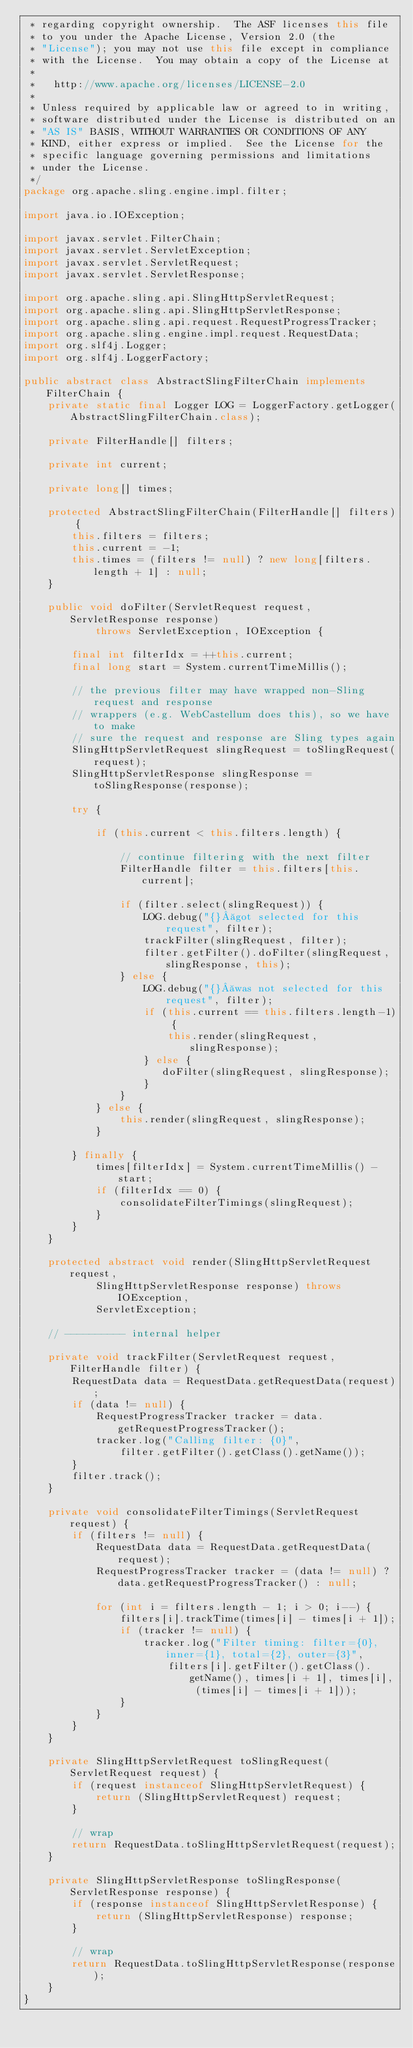<code> <loc_0><loc_0><loc_500><loc_500><_Java_> * regarding copyright ownership.  The ASF licenses this file
 * to you under the Apache License, Version 2.0 (the
 * "License"); you may not use this file except in compliance
 * with the License.  You may obtain a copy of the License at
 *
 *   http://www.apache.org/licenses/LICENSE-2.0
 *
 * Unless required by applicable law or agreed to in writing,
 * software distributed under the License is distributed on an
 * "AS IS" BASIS, WITHOUT WARRANTIES OR CONDITIONS OF ANY
 * KIND, either express or implied.  See the License for the
 * specific language governing permissions and limitations
 * under the License.
 */
package org.apache.sling.engine.impl.filter;

import java.io.IOException;

import javax.servlet.FilterChain;
import javax.servlet.ServletException;
import javax.servlet.ServletRequest;
import javax.servlet.ServletResponse;

import org.apache.sling.api.SlingHttpServletRequest;
import org.apache.sling.api.SlingHttpServletResponse;
import org.apache.sling.api.request.RequestProgressTracker;
import org.apache.sling.engine.impl.request.RequestData;
import org.slf4j.Logger;
import org.slf4j.LoggerFactory;

public abstract class AbstractSlingFilterChain implements FilterChain {
    private static final Logger LOG = LoggerFactory.getLogger(AbstractSlingFilterChain.class);

    private FilterHandle[] filters;

    private int current;

    private long[] times;

    protected AbstractSlingFilterChain(FilterHandle[] filters) {
        this.filters = filters;
        this.current = -1;
        this.times = (filters != null) ? new long[filters.length + 1] : null;
    }

    public void doFilter(ServletRequest request, ServletResponse response)
            throws ServletException, IOException {

        final int filterIdx = ++this.current;
        final long start = System.currentTimeMillis();

        // the previous filter may have wrapped non-Sling request and response
        // wrappers (e.g. WebCastellum does this), so we have to make
        // sure the request and response are Sling types again
        SlingHttpServletRequest slingRequest = toSlingRequest(request);
        SlingHttpServletResponse slingResponse = toSlingResponse(response);

        try {

            if (this.current < this.filters.length) {

                // continue filtering with the next filter
                FilterHandle filter = this.filters[this.current];
                
                if (filter.select(slingRequest)) {
                    LOG.debug("{} got selected for this request", filter);
                    trackFilter(slingRequest, filter);
                    filter.getFilter().doFilter(slingRequest, slingResponse, this);
                } else {
                    LOG.debug("{} was not selected for this request", filter);
                    if (this.current == this.filters.length-1) {
                        this.render(slingRequest, slingResponse);
                    } else {
                       doFilter(slingRequest, slingResponse);
                    }
                }
            } else {
                this.render(slingRequest, slingResponse);
            }

        } finally {
            times[filterIdx] = System.currentTimeMillis() - start;
            if (filterIdx == 0) {
                consolidateFilterTimings(slingRequest);
            }
        }
    }

    protected abstract void render(SlingHttpServletRequest request,
            SlingHttpServletResponse response) throws IOException,
            ServletException;

    // ---------- internal helper

    private void trackFilter(ServletRequest request, FilterHandle filter) {
        RequestData data = RequestData.getRequestData(request);
        if (data != null) {
            RequestProgressTracker tracker = data.getRequestProgressTracker();
            tracker.log("Calling filter: {0}",
                filter.getFilter().getClass().getName());
        }
        filter.track();
    }

    private void consolidateFilterTimings(ServletRequest request) {
        if (filters != null) {
            RequestData data = RequestData.getRequestData(request);
            RequestProgressTracker tracker = (data != null) ? data.getRequestProgressTracker() : null;

            for (int i = filters.length - 1; i > 0; i--) {
                filters[i].trackTime(times[i] - times[i + 1]);
                if (tracker != null) {
                    tracker.log("Filter timing: filter={0}, inner={1}, total={2}, outer={3}",
                        filters[i].getFilter().getClass().getName(), times[i + 1], times[i], (times[i] - times[i + 1]));
                }
            }
        }
    }

    private SlingHttpServletRequest toSlingRequest(ServletRequest request) {
        if (request instanceof SlingHttpServletRequest) {
            return (SlingHttpServletRequest) request;
        }

        // wrap
        return RequestData.toSlingHttpServletRequest(request);
    }

    private SlingHttpServletResponse toSlingResponse(ServletResponse response) {
        if (response instanceof SlingHttpServletResponse) {
            return (SlingHttpServletResponse) response;
        }

        // wrap
        return RequestData.toSlingHttpServletResponse(response);
    }
}</code> 